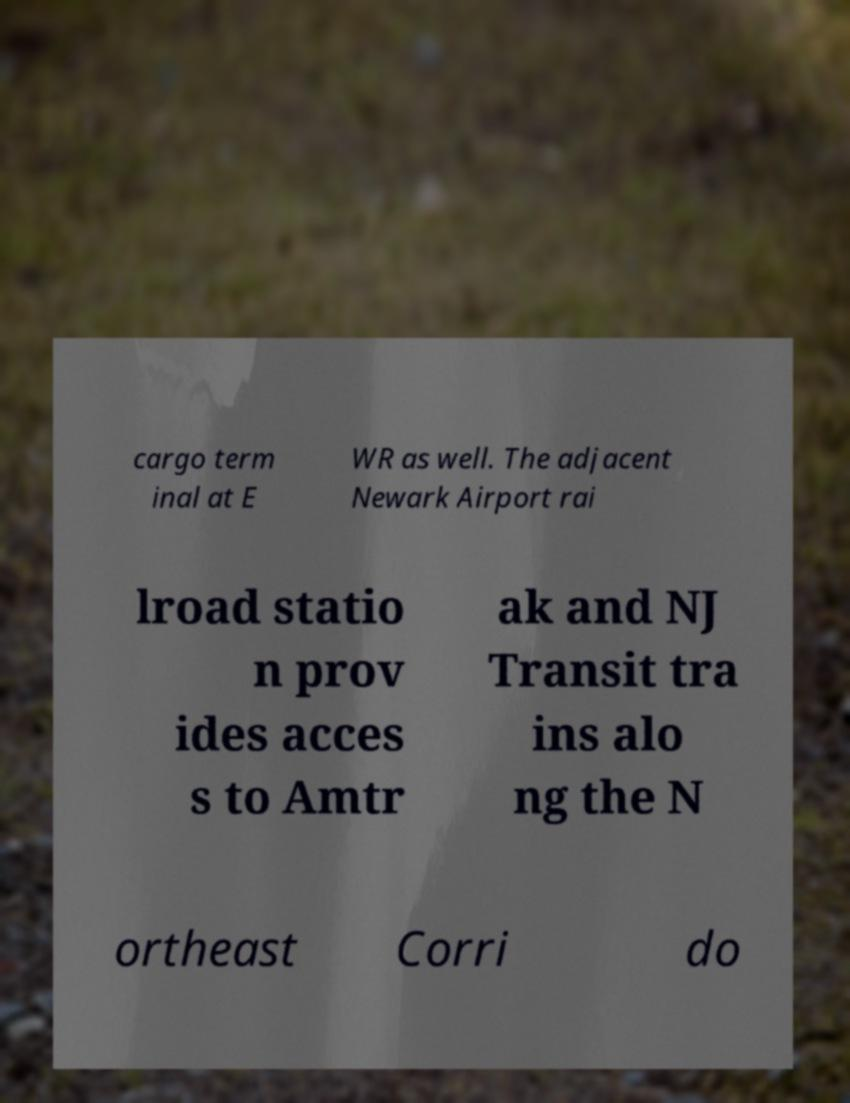Please identify and transcribe the text found in this image. cargo term inal at E WR as well. The adjacent Newark Airport rai lroad statio n prov ides acces s to Amtr ak and NJ Transit tra ins alo ng the N ortheast Corri do 